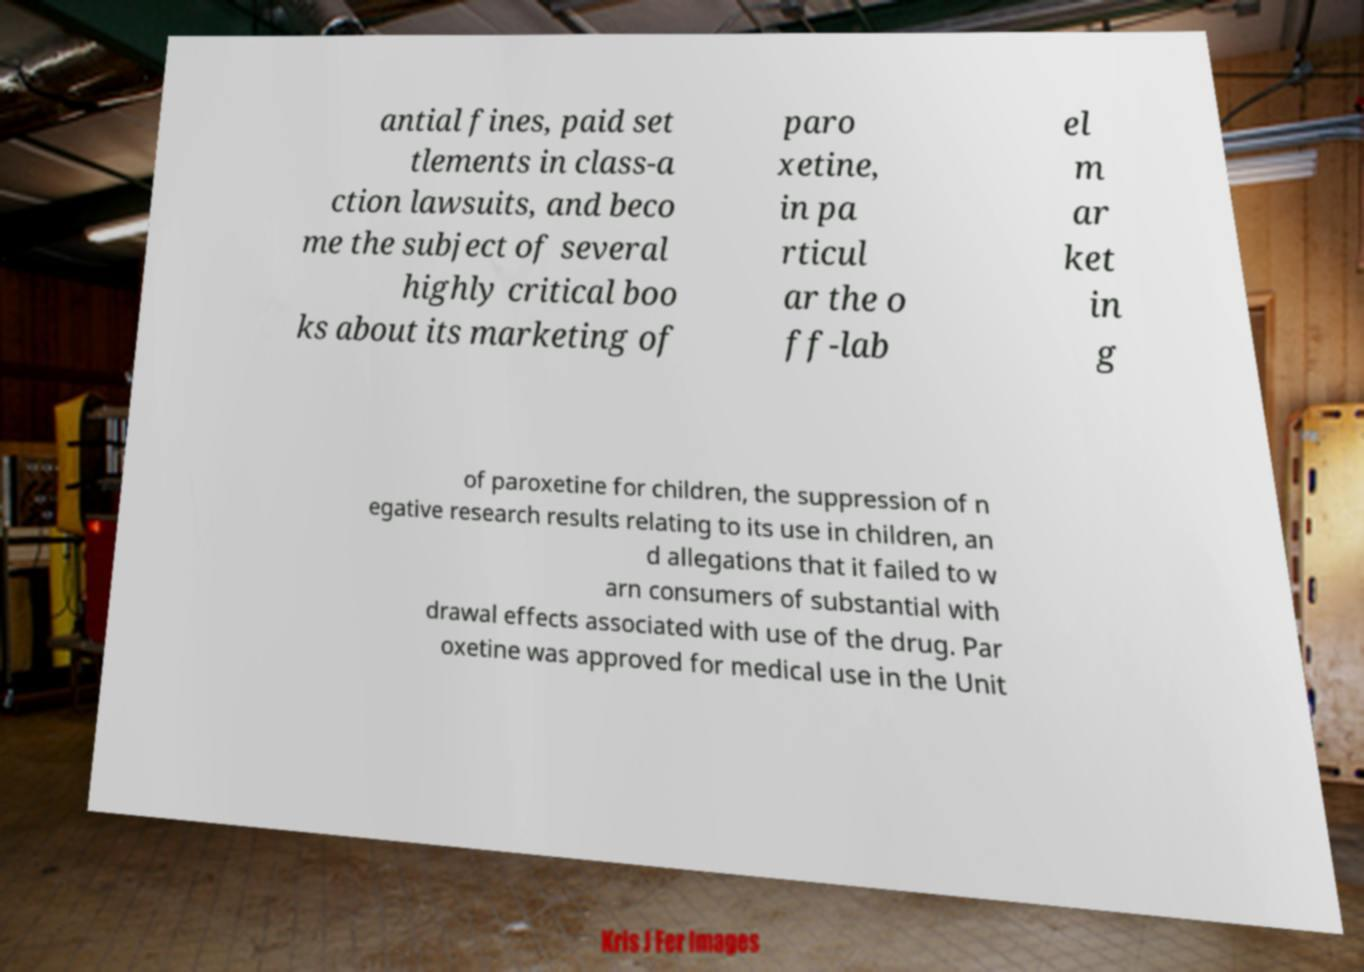Can you accurately transcribe the text from the provided image for me? antial fines, paid set tlements in class-a ction lawsuits, and beco me the subject of several highly critical boo ks about its marketing of paro xetine, in pa rticul ar the o ff-lab el m ar ket in g of paroxetine for children, the suppression of n egative research results relating to its use in children, an d allegations that it failed to w arn consumers of substantial with drawal effects associated with use of the drug. Par oxetine was approved for medical use in the Unit 